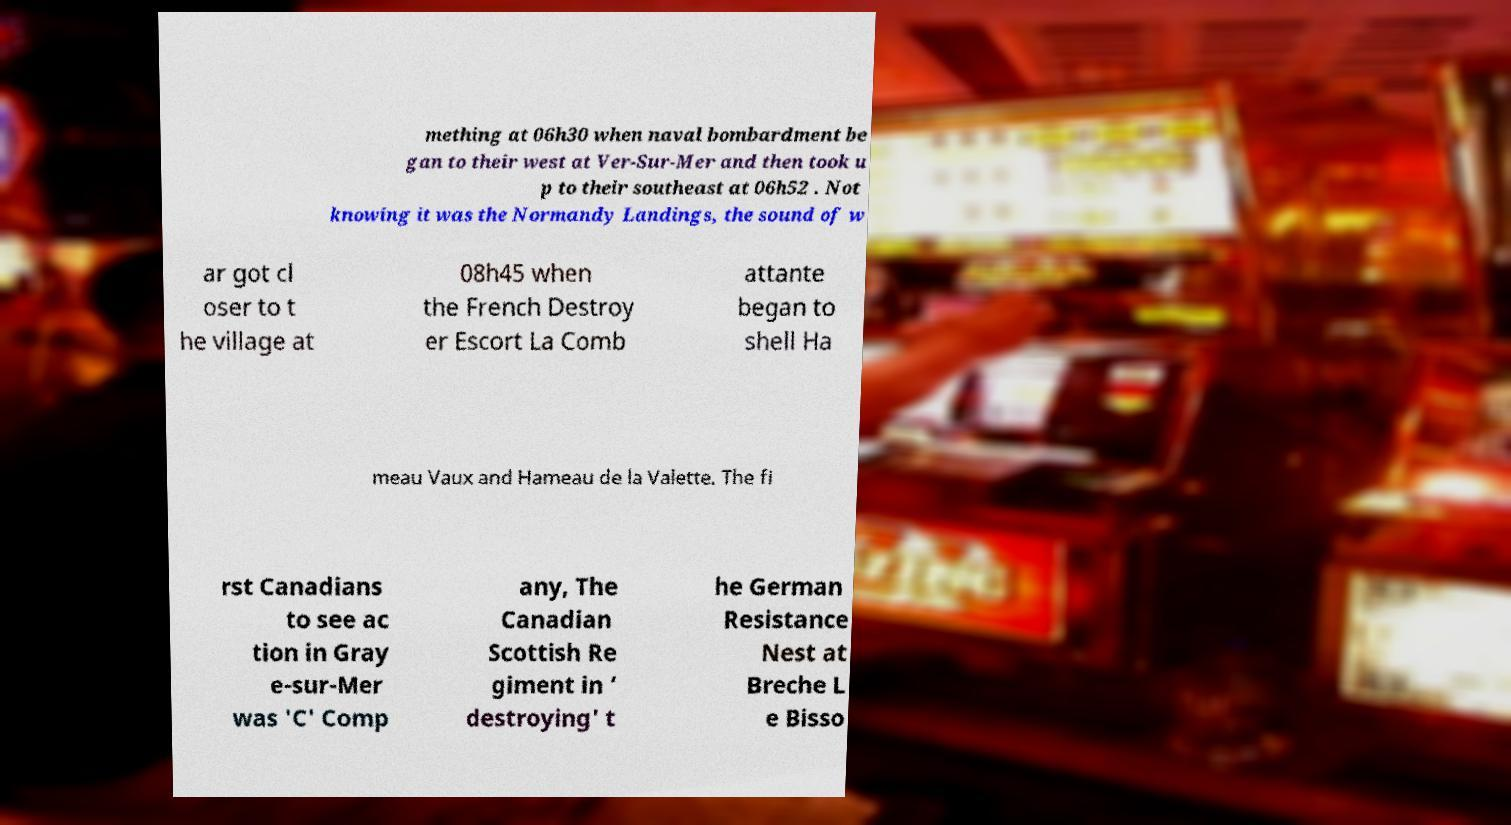There's text embedded in this image that I need extracted. Can you transcribe it verbatim? mething at 06h30 when naval bombardment be gan to their west at Ver-Sur-Mer and then took u p to their southeast at 06h52 . Not knowing it was the Normandy Landings, the sound of w ar got cl oser to t he village at 08h45 when the French Destroy er Escort La Comb attante began to shell Ha meau Vaux and Hameau de la Valette. The fi rst Canadians to see ac tion in Gray e-sur-Mer was 'C' Comp any, The Canadian Scottish Re giment in ‘ destroying' t he German Resistance Nest at Breche L e Bisso 